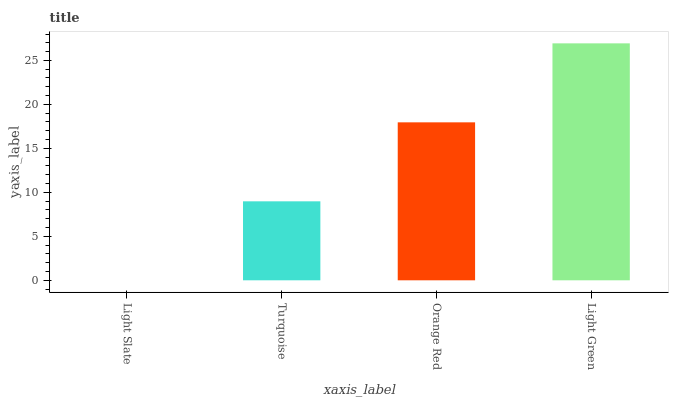Is Light Slate the minimum?
Answer yes or no. Yes. Is Light Green the maximum?
Answer yes or no. Yes. Is Turquoise the minimum?
Answer yes or no. No. Is Turquoise the maximum?
Answer yes or no. No. Is Turquoise greater than Light Slate?
Answer yes or no. Yes. Is Light Slate less than Turquoise?
Answer yes or no. Yes. Is Light Slate greater than Turquoise?
Answer yes or no. No. Is Turquoise less than Light Slate?
Answer yes or no. No. Is Orange Red the high median?
Answer yes or no. Yes. Is Turquoise the low median?
Answer yes or no. Yes. Is Turquoise the high median?
Answer yes or no. No. Is Light Slate the low median?
Answer yes or no. No. 